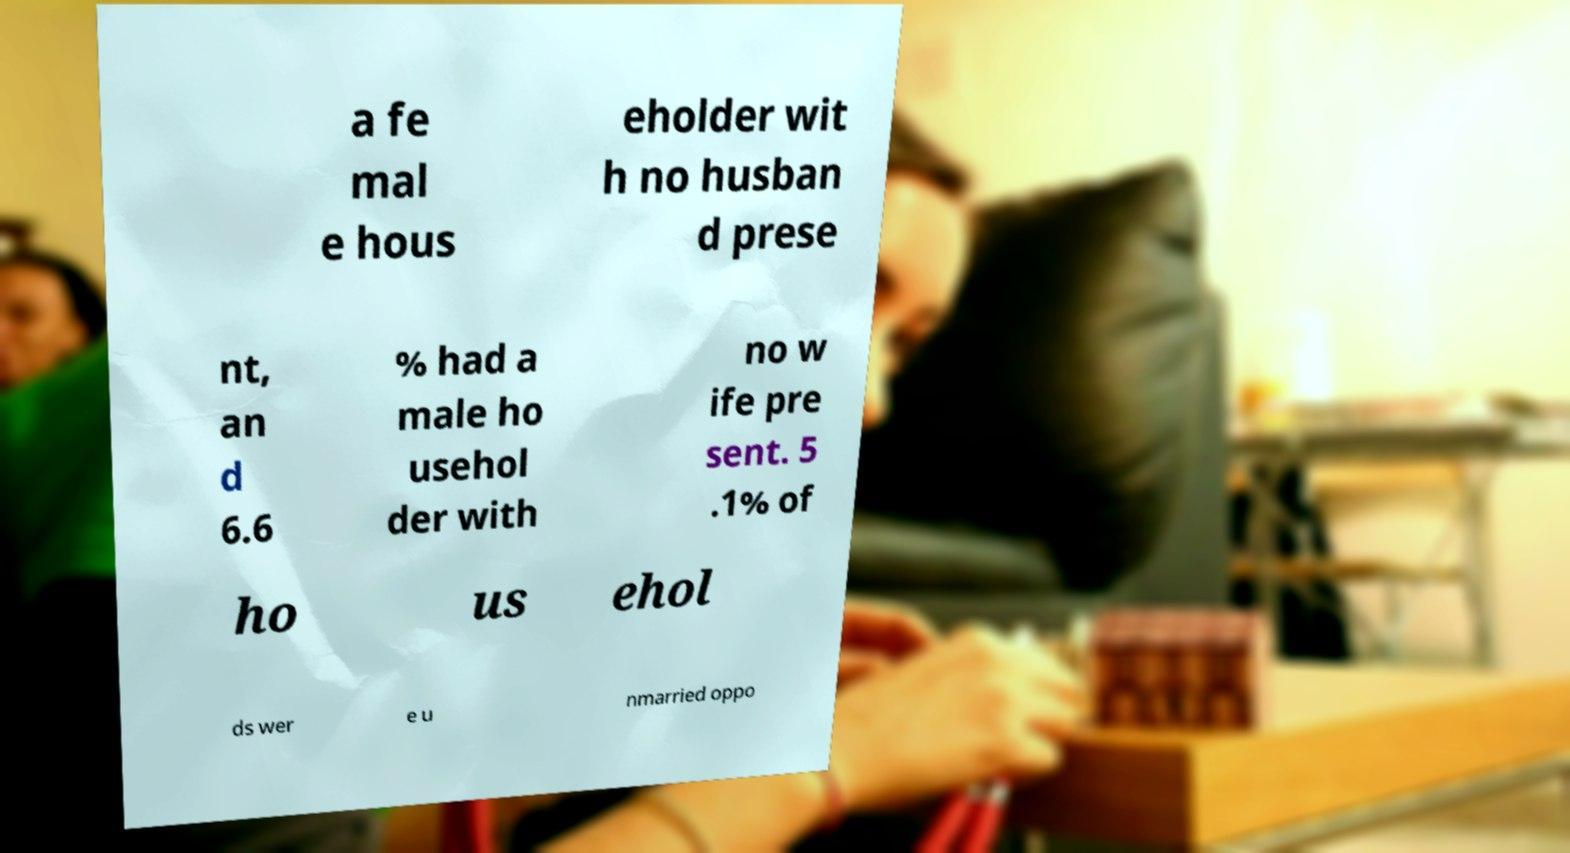For documentation purposes, I need the text within this image transcribed. Could you provide that? a fe mal e hous eholder wit h no husban d prese nt, an d 6.6 % had a male ho usehol der with no w ife pre sent. 5 .1% of ho us ehol ds wer e u nmarried oppo 